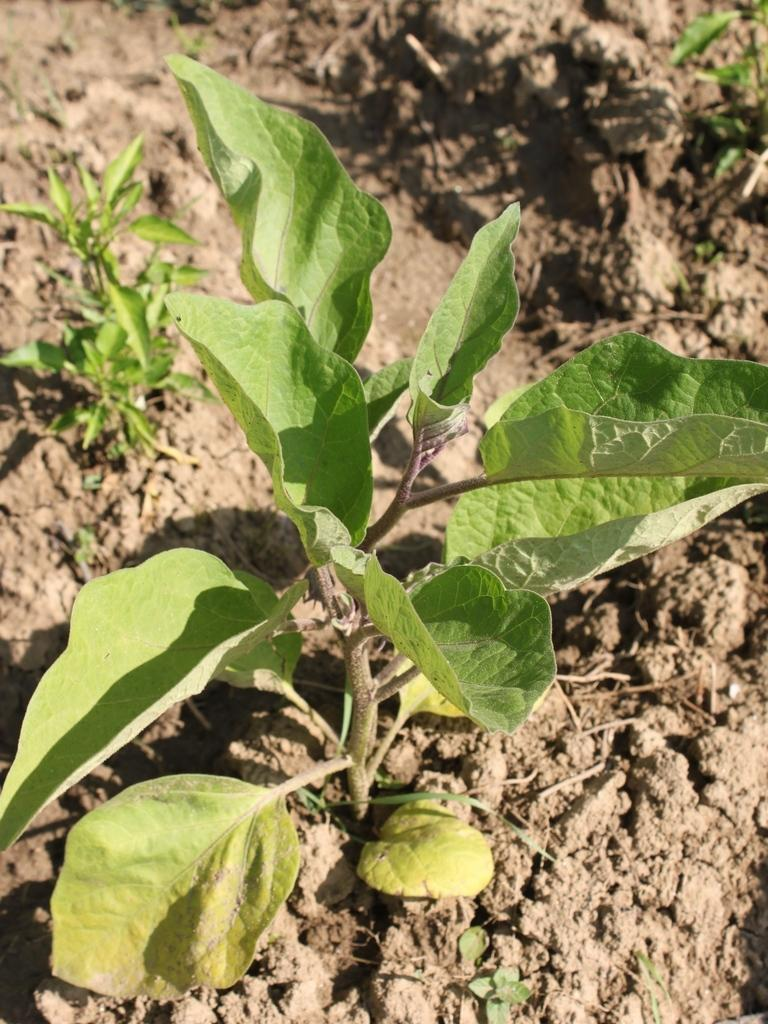What celestial bodies are depicted in the image? There are planets in the image. What type of surface is visible at the bottom of the image? There is soil visible at the bottom of the image. What type of camera is being used to take a picture of the jelly in the image? There is no camera or jelly present in the image; it features planets and soil. What is the nail being used for in the image? There is no nail present in the image. 